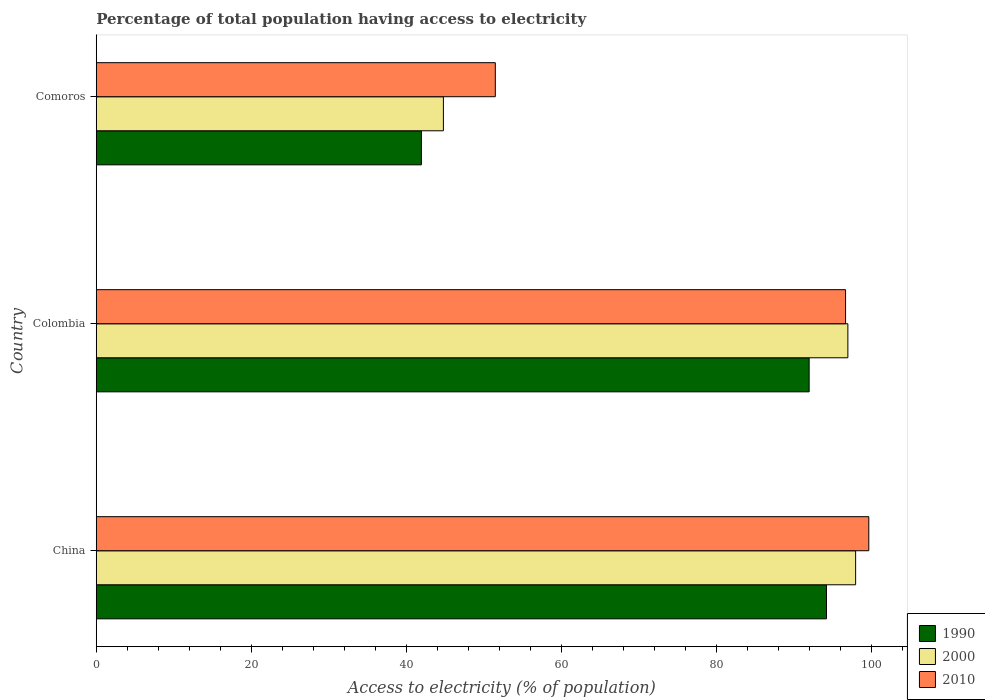How many groups of bars are there?
Offer a terse response. 3. Are the number of bars per tick equal to the number of legend labels?
Keep it short and to the point. Yes. What is the label of the 1st group of bars from the top?
Keep it short and to the point. Comoros. In how many cases, is the number of bars for a given country not equal to the number of legend labels?
Provide a short and direct response. 0. What is the percentage of population that have access to electricity in 2010 in Colombia?
Provide a short and direct response. 96.7. Across all countries, what is the minimum percentage of population that have access to electricity in 2000?
Provide a short and direct response. 44.8. In which country was the percentage of population that have access to electricity in 2000 minimum?
Your answer should be very brief. Comoros. What is the total percentage of population that have access to electricity in 2000 in the graph?
Keep it short and to the point. 239.8. What is the difference between the percentage of population that have access to electricity in 2010 in Colombia and that in Comoros?
Your answer should be compact. 45.2. What is the difference between the percentage of population that have access to electricity in 2010 in Comoros and the percentage of population that have access to electricity in 2000 in Colombia?
Give a very brief answer. -45.5. What is the average percentage of population that have access to electricity in 2000 per country?
Provide a succinct answer. 79.93. What is the difference between the percentage of population that have access to electricity in 2010 and percentage of population that have access to electricity in 2000 in China?
Make the answer very short. 1.7. What is the ratio of the percentage of population that have access to electricity in 1990 in China to that in Colombia?
Keep it short and to the point. 1.02. Is the percentage of population that have access to electricity in 1990 in China less than that in Comoros?
Offer a terse response. No. What is the difference between the highest and the second highest percentage of population that have access to electricity in 1990?
Ensure brevity in your answer.  2.24. What is the difference between the highest and the lowest percentage of population that have access to electricity in 2010?
Make the answer very short. 48.2. Is the sum of the percentage of population that have access to electricity in 2010 in Colombia and Comoros greater than the maximum percentage of population that have access to electricity in 1990 across all countries?
Provide a short and direct response. Yes. What does the 3rd bar from the bottom in China represents?
Offer a terse response. 2010. How many bars are there?
Provide a succinct answer. 9. How many countries are there in the graph?
Your response must be concise. 3. Are the values on the major ticks of X-axis written in scientific E-notation?
Offer a very short reply. No. Does the graph contain any zero values?
Offer a very short reply. No. Where does the legend appear in the graph?
Your answer should be compact. Bottom right. How many legend labels are there?
Provide a succinct answer. 3. What is the title of the graph?
Your answer should be very brief. Percentage of total population having access to electricity. Does "1964" appear as one of the legend labels in the graph?
Give a very brief answer. No. What is the label or title of the X-axis?
Make the answer very short. Access to electricity (% of population). What is the Access to electricity (% of population) of 1990 in China?
Your response must be concise. 94.24. What is the Access to electricity (% of population) of 2010 in China?
Provide a short and direct response. 99.7. What is the Access to electricity (% of population) of 1990 in Colombia?
Ensure brevity in your answer.  92. What is the Access to electricity (% of population) of 2000 in Colombia?
Give a very brief answer. 97. What is the Access to electricity (% of population) of 2010 in Colombia?
Give a very brief answer. 96.7. What is the Access to electricity (% of population) in 1990 in Comoros?
Offer a terse response. 41.96. What is the Access to electricity (% of population) in 2000 in Comoros?
Make the answer very short. 44.8. What is the Access to electricity (% of population) in 2010 in Comoros?
Provide a short and direct response. 51.5. Across all countries, what is the maximum Access to electricity (% of population) of 1990?
Ensure brevity in your answer.  94.24. Across all countries, what is the maximum Access to electricity (% of population) of 2000?
Offer a very short reply. 98. Across all countries, what is the maximum Access to electricity (% of population) of 2010?
Provide a short and direct response. 99.7. Across all countries, what is the minimum Access to electricity (% of population) in 1990?
Make the answer very short. 41.96. Across all countries, what is the minimum Access to electricity (% of population) of 2000?
Ensure brevity in your answer.  44.8. Across all countries, what is the minimum Access to electricity (% of population) of 2010?
Give a very brief answer. 51.5. What is the total Access to electricity (% of population) in 1990 in the graph?
Your answer should be very brief. 228.2. What is the total Access to electricity (% of population) in 2000 in the graph?
Your response must be concise. 239.8. What is the total Access to electricity (% of population) in 2010 in the graph?
Provide a short and direct response. 247.9. What is the difference between the Access to electricity (% of population) in 1990 in China and that in Colombia?
Offer a very short reply. 2.24. What is the difference between the Access to electricity (% of population) of 2000 in China and that in Colombia?
Ensure brevity in your answer.  1. What is the difference between the Access to electricity (% of population) of 1990 in China and that in Comoros?
Your answer should be very brief. 52.28. What is the difference between the Access to electricity (% of population) of 2000 in China and that in Comoros?
Ensure brevity in your answer.  53.2. What is the difference between the Access to electricity (% of population) of 2010 in China and that in Comoros?
Your answer should be compact. 48.2. What is the difference between the Access to electricity (% of population) in 1990 in Colombia and that in Comoros?
Ensure brevity in your answer.  50.04. What is the difference between the Access to electricity (% of population) in 2000 in Colombia and that in Comoros?
Make the answer very short. 52.2. What is the difference between the Access to electricity (% of population) in 2010 in Colombia and that in Comoros?
Your answer should be very brief. 45.2. What is the difference between the Access to electricity (% of population) in 1990 in China and the Access to electricity (% of population) in 2000 in Colombia?
Your answer should be compact. -2.76. What is the difference between the Access to electricity (% of population) of 1990 in China and the Access to electricity (% of population) of 2010 in Colombia?
Your answer should be compact. -2.46. What is the difference between the Access to electricity (% of population) of 1990 in China and the Access to electricity (% of population) of 2000 in Comoros?
Your answer should be compact. 49.44. What is the difference between the Access to electricity (% of population) in 1990 in China and the Access to electricity (% of population) in 2010 in Comoros?
Provide a succinct answer. 42.74. What is the difference between the Access to electricity (% of population) of 2000 in China and the Access to electricity (% of population) of 2010 in Comoros?
Offer a terse response. 46.5. What is the difference between the Access to electricity (% of population) of 1990 in Colombia and the Access to electricity (% of population) of 2000 in Comoros?
Your response must be concise. 47.2. What is the difference between the Access to electricity (% of population) of 1990 in Colombia and the Access to electricity (% of population) of 2010 in Comoros?
Your response must be concise. 40.5. What is the difference between the Access to electricity (% of population) of 2000 in Colombia and the Access to electricity (% of population) of 2010 in Comoros?
Offer a very short reply. 45.5. What is the average Access to electricity (% of population) of 1990 per country?
Provide a short and direct response. 76.07. What is the average Access to electricity (% of population) in 2000 per country?
Provide a succinct answer. 79.93. What is the average Access to electricity (% of population) in 2010 per country?
Offer a very short reply. 82.63. What is the difference between the Access to electricity (% of population) in 1990 and Access to electricity (% of population) in 2000 in China?
Keep it short and to the point. -3.76. What is the difference between the Access to electricity (% of population) in 1990 and Access to electricity (% of population) in 2010 in China?
Offer a very short reply. -5.46. What is the difference between the Access to electricity (% of population) in 1990 and Access to electricity (% of population) in 2000 in Comoros?
Ensure brevity in your answer.  -2.84. What is the difference between the Access to electricity (% of population) of 1990 and Access to electricity (% of population) of 2010 in Comoros?
Give a very brief answer. -9.54. What is the ratio of the Access to electricity (% of population) of 1990 in China to that in Colombia?
Your response must be concise. 1.02. What is the ratio of the Access to electricity (% of population) in 2000 in China to that in Colombia?
Your answer should be compact. 1.01. What is the ratio of the Access to electricity (% of population) in 2010 in China to that in Colombia?
Offer a terse response. 1.03. What is the ratio of the Access to electricity (% of population) in 1990 in China to that in Comoros?
Give a very brief answer. 2.25. What is the ratio of the Access to electricity (% of population) in 2000 in China to that in Comoros?
Keep it short and to the point. 2.19. What is the ratio of the Access to electricity (% of population) of 2010 in China to that in Comoros?
Make the answer very short. 1.94. What is the ratio of the Access to electricity (% of population) of 1990 in Colombia to that in Comoros?
Ensure brevity in your answer.  2.19. What is the ratio of the Access to electricity (% of population) of 2000 in Colombia to that in Comoros?
Your answer should be very brief. 2.17. What is the ratio of the Access to electricity (% of population) of 2010 in Colombia to that in Comoros?
Your response must be concise. 1.88. What is the difference between the highest and the second highest Access to electricity (% of population) of 1990?
Offer a terse response. 2.24. What is the difference between the highest and the second highest Access to electricity (% of population) of 2000?
Offer a very short reply. 1. What is the difference between the highest and the lowest Access to electricity (% of population) of 1990?
Give a very brief answer. 52.28. What is the difference between the highest and the lowest Access to electricity (% of population) in 2000?
Provide a succinct answer. 53.2. What is the difference between the highest and the lowest Access to electricity (% of population) of 2010?
Your answer should be compact. 48.2. 